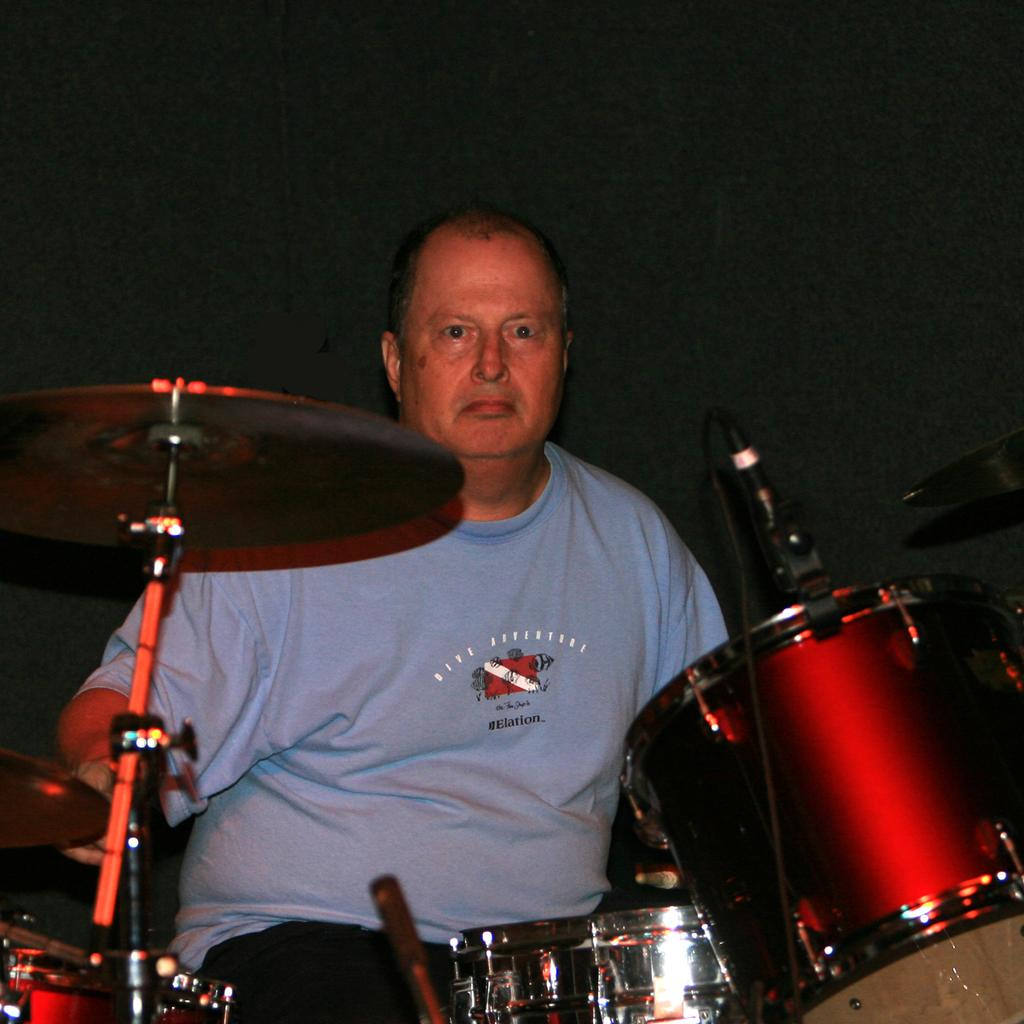What type of musical instruments are in the image? There are drums in the image. What other percussion instrument can be seen in the image? There is a crash cymbal on a cymbal stand in the image. Can you describe the person in the background of the image? Unfortunately, the facts provided do not give any details about the person in the background. What type of structure is the person in the background of the image holding? There is no structure mentioned in the image, and the person's actions are not described. What effect does the music have on the babies in the image? There are no babies mentioned in the image, so it is impossible to determine any effect the music might have on them. 